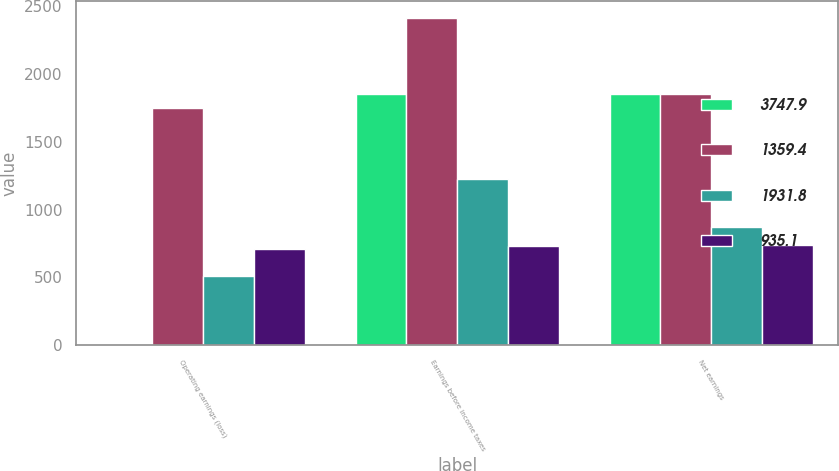Convert chart. <chart><loc_0><loc_0><loc_500><loc_500><stacked_bar_chart><ecel><fcel>Operating earnings (loss)<fcel>Earnings before income taxes<fcel>Net earnings<nl><fcel>3747.9<fcel>2.5<fcel>1848.7<fcel>1848.7<nl><fcel>1359.4<fcel>1746.2<fcel>2413.6<fcel>1851.2<nl><fcel>1931.8<fcel>513.6<fcel>1222.4<fcel>868.3<nl><fcel>935.1<fcel>709.4<fcel>728.5<fcel>738.9<nl></chart> 